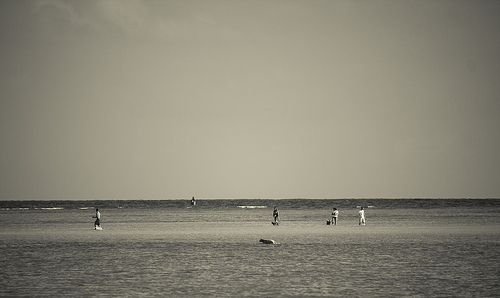[0.18, 0.61, 0.56, 0.65]. Within this region, two individuals appear to be engaged in a leisurely walk along the shoreline, both dressed in dark attire that contrasts with the pale sands. 